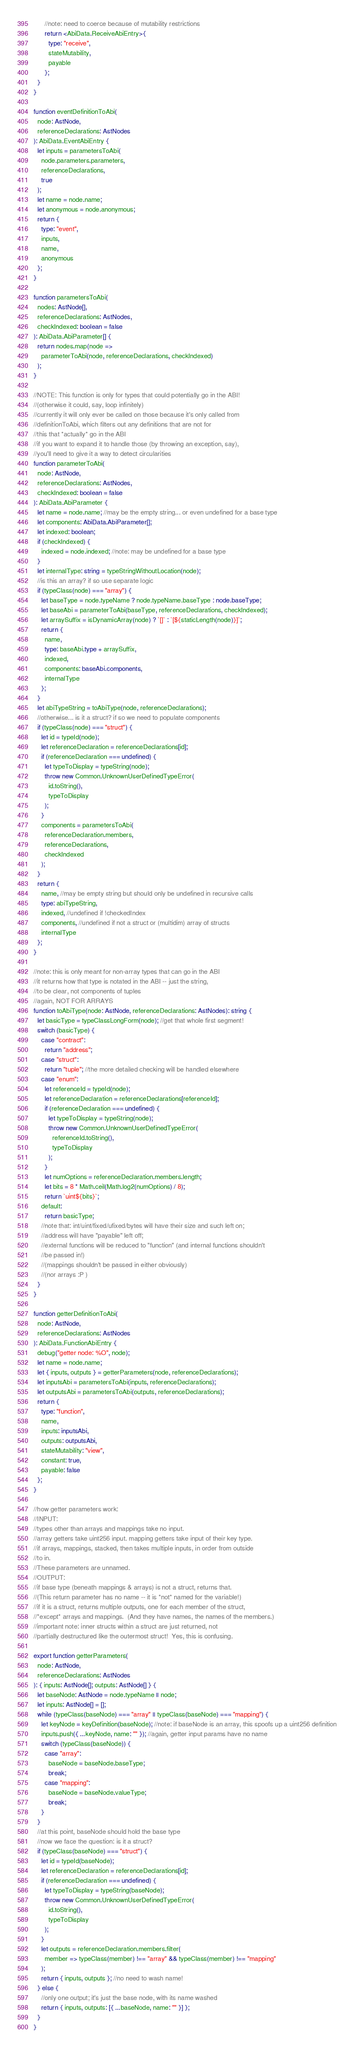<code> <loc_0><loc_0><loc_500><loc_500><_TypeScript_>      //note: need to coerce because of mutability restrictions
      return <AbiData.ReceiveAbiEntry>{
        type: "receive",
        stateMutability,
        payable
      };
  }
}

function eventDefinitionToAbi(
  node: AstNode,
  referenceDeclarations: AstNodes
): AbiData.EventAbiEntry {
  let inputs = parametersToAbi(
    node.parameters.parameters,
    referenceDeclarations,
    true
  );
  let name = node.name;
  let anonymous = node.anonymous;
  return {
    type: "event",
    inputs,
    name,
    anonymous
  };
}

function parametersToAbi(
  nodes: AstNode[],
  referenceDeclarations: AstNodes,
  checkIndexed: boolean = false
): AbiData.AbiParameter[] {
  return nodes.map(node =>
    parameterToAbi(node, referenceDeclarations, checkIndexed)
  );
}

//NOTE: This function is only for types that could potentially go in the ABI!
//(otherwise it could, say, loop infinitely)
//currently it will only ever be called on those because it's only called from
//definitionToAbi, which filters out any definitions that are not for
//this that *actually* go in the ABI
//if you want to expand it to handle those (by throwing an exception, say),
//you'll need to give it a way to detect circularities
function parameterToAbi(
  node: AstNode,
  referenceDeclarations: AstNodes,
  checkIndexed: boolean = false
): AbiData.AbiParameter {
  let name = node.name; //may be the empty string... or even undefined for a base type
  let components: AbiData.AbiParameter[];
  let indexed: boolean;
  if (checkIndexed) {
    indexed = node.indexed; //note: may be undefined for a base type
  }
  let internalType: string = typeStringWithoutLocation(node);
  //is this an array? if so use separate logic
  if (typeClass(node) === "array") {
    let baseType = node.typeName ? node.typeName.baseType : node.baseType;
    let baseAbi = parameterToAbi(baseType, referenceDeclarations, checkIndexed);
    let arraySuffix = isDynamicArray(node) ? `[]` : `[${staticLength(node)}]`;
    return {
      name,
      type: baseAbi.type + arraySuffix,
      indexed,
      components: baseAbi.components,
      internalType
    };
  }
  let abiTypeString = toAbiType(node, referenceDeclarations);
  //otherwise... is it a struct? if so we need to populate components
  if (typeClass(node) === "struct") {
    let id = typeId(node);
    let referenceDeclaration = referenceDeclarations[id];
    if (referenceDeclaration === undefined) {
      let typeToDisplay = typeString(node);
      throw new Common.UnknownUserDefinedTypeError(
        id.toString(),
        typeToDisplay
      );
    }
    components = parametersToAbi(
      referenceDeclaration.members,
      referenceDeclarations,
      checkIndexed
    );
  }
  return {
    name, //may be empty string but should only be undefined in recursive calls
    type: abiTypeString,
    indexed, //undefined if !checkedIndex
    components, //undefined if not a struct or (multidim) array of structs
    internalType
  };
}

//note: this is only meant for non-array types that can go in the ABI
//it returns how that type is notated in the ABI -- just the string,
//to be clear, not components of tuples
//again, NOT FOR ARRAYS
function toAbiType(node: AstNode, referenceDeclarations: AstNodes): string {
  let basicType = typeClassLongForm(node); //get that whole first segment!
  switch (basicType) {
    case "contract":
      return "address";
    case "struct":
      return "tuple"; //the more detailed checking will be handled elsewhere
    case "enum":
      let referenceId = typeId(node);
      let referenceDeclaration = referenceDeclarations[referenceId];
      if (referenceDeclaration === undefined) {
        let typeToDisplay = typeString(node);
        throw new Common.UnknownUserDefinedTypeError(
          referenceId.toString(),
          typeToDisplay
        );
      }
      let numOptions = referenceDeclaration.members.length;
      let bits = 8 * Math.ceil(Math.log2(numOptions) / 8);
      return `uint${bits}`;
    default:
      return basicType;
    //note that: int/uint/fixed/ufixed/bytes will have their size and such left on;
    //address will have "payable" left off;
    //external functions will be reduced to "function" (and internal functions shouldn't
    //be passed in!)
    //(mappings shouldn't be passed in either obviously)
    //(nor arrays :P )
  }
}

function getterDefinitionToAbi(
  node: AstNode,
  referenceDeclarations: AstNodes
): AbiData.FunctionAbiEntry {
  debug("getter node: %O", node);
  let name = node.name;
  let { inputs, outputs } = getterParameters(node, referenceDeclarations);
  let inputsAbi = parametersToAbi(inputs, referenceDeclarations);
  let outputsAbi = parametersToAbi(outputs, referenceDeclarations);
  return {
    type: "function",
    name,
    inputs: inputsAbi,
    outputs: outputsAbi,
    stateMutability: "view",
    constant: true,
    payable: false
  };
}

//how getter parameters work:
//INPUT:
//types other than arrays and mappings take no input.
//array getters take uint256 input. mapping getters take input of their key type.
//if arrays, mappings, stacked, then takes multiple inputs, in order from outside
//to in.
//These parameters are unnamed.
//OUTPUT:
//if base type (beneath mappings & arrays) is not a struct, returns that.
//(This return parameter has no name -- it is *not* named for the variable!)
//if it is a struct, returns multiple outputs, one for each member of the struct,
//*except* arrays and mappings.  (And they have names, the names of the members.)
//important note: inner structs within a struct are just returned, not
//partially destructured like the outermost struct!  Yes, this is confusing.

export function getterParameters(
  node: AstNode,
  referenceDeclarations: AstNodes
): { inputs: AstNode[]; outputs: AstNode[] } {
  let baseNode: AstNode = node.typeName || node;
  let inputs: AstNode[] = [];
  while (typeClass(baseNode) === "array" || typeClass(baseNode) === "mapping") {
    let keyNode = keyDefinition(baseNode); //note: if baseNode is an array, this spoofs up a uint256 definition
    inputs.push({ ...keyNode, name: "" }); //again, getter input params have no name
    switch (typeClass(baseNode)) {
      case "array":
        baseNode = baseNode.baseType;
        break;
      case "mapping":
        baseNode = baseNode.valueType;
        break;
    }
  }
  //at this point, baseNode should hold the base type
  //now we face the question: is it a struct?
  if (typeClass(baseNode) === "struct") {
    let id = typeId(baseNode);
    let referenceDeclaration = referenceDeclarations[id];
    if (referenceDeclaration === undefined) {
      let typeToDisplay = typeString(baseNode);
      throw new Common.UnknownUserDefinedTypeError(
        id.toString(),
        typeToDisplay
      );
    }
    let outputs = referenceDeclaration.members.filter(
      member => typeClass(member) !== "array" && typeClass(member) !== "mapping"
    );
    return { inputs, outputs }; //no need to wash name!
  } else {
    //only one output; it's just the base node, with its name washed
    return { inputs, outputs: [{ ...baseNode, name: "" }] };
  }
}
</code> 